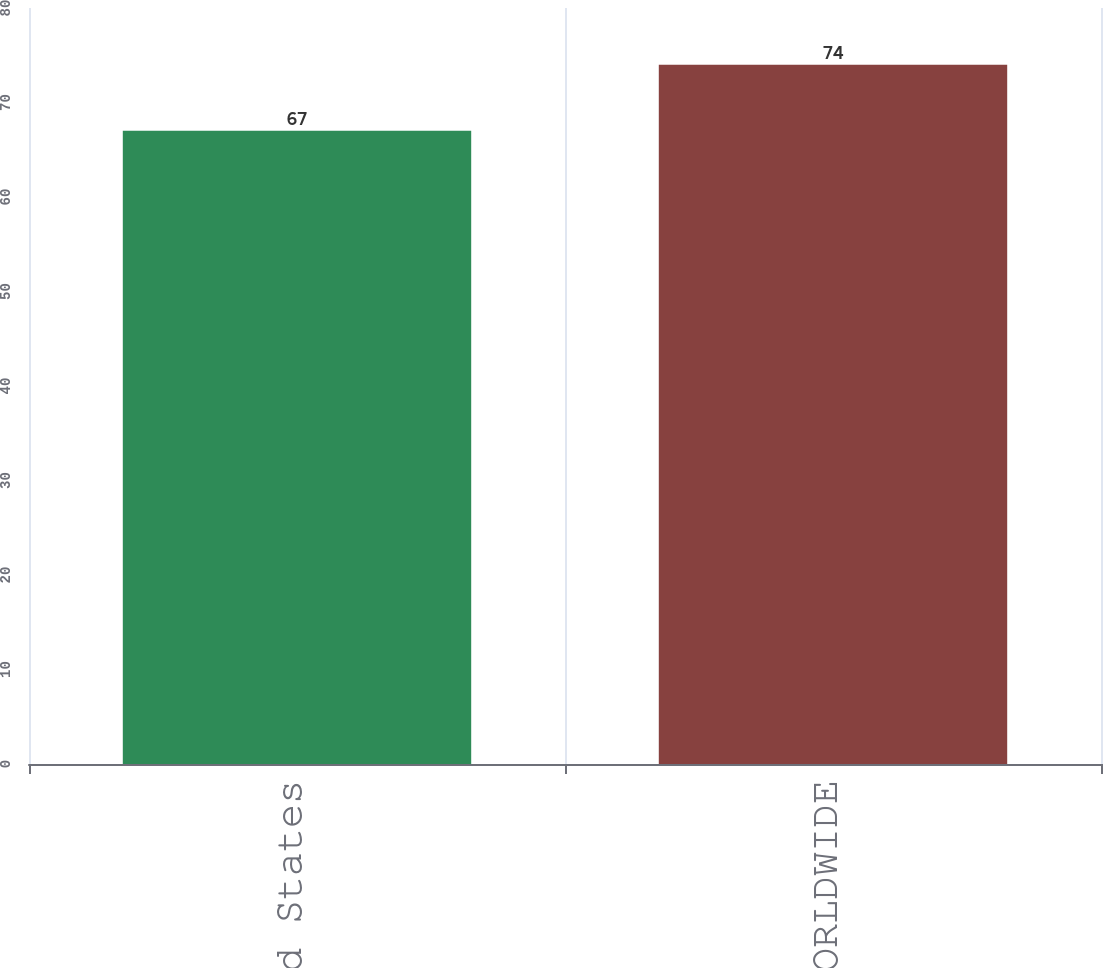Convert chart. <chart><loc_0><loc_0><loc_500><loc_500><bar_chart><fcel>United States<fcel>WORLDWIDE<nl><fcel>67<fcel>74<nl></chart> 